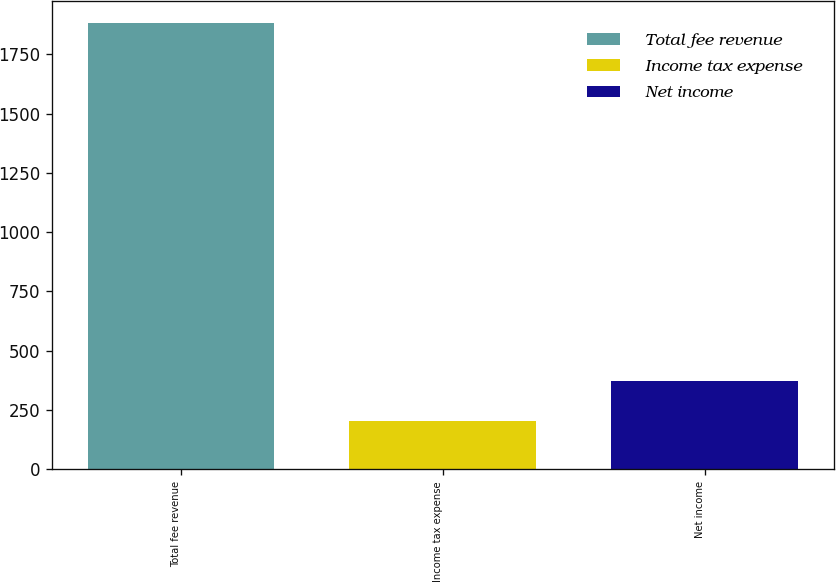Convert chart. <chart><loc_0><loc_0><loc_500><loc_500><bar_chart><fcel>Total fee revenue<fcel>Income tax expense<fcel>Net income<nl><fcel>1881<fcel>205<fcel>372.6<nl></chart> 